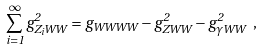Convert formula to latex. <formula><loc_0><loc_0><loc_500><loc_500>\sum _ { i = 1 } ^ { \infty } g _ { Z _ { i } W W } ^ { 2 } = g _ { W W W W } - g _ { Z W W } ^ { 2 } - g _ { \gamma W W } ^ { 2 } \ ,</formula> 